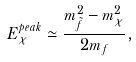<formula> <loc_0><loc_0><loc_500><loc_500>E ^ { p e a k } _ { \chi } \simeq \frac { m ^ { 2 } _ { \tilde { f } } - m _ { \chi } ^ { 2 } } { 2 m _ { f } } ,</formula> 